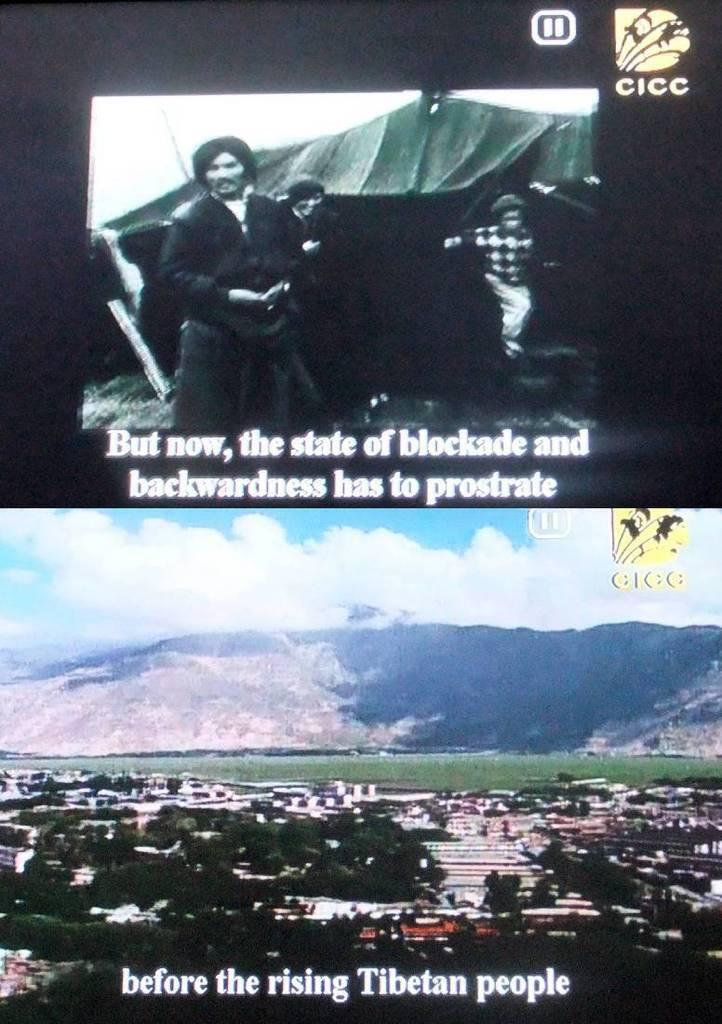What channel is this show on?
Your answer should be compact. Cicc. 